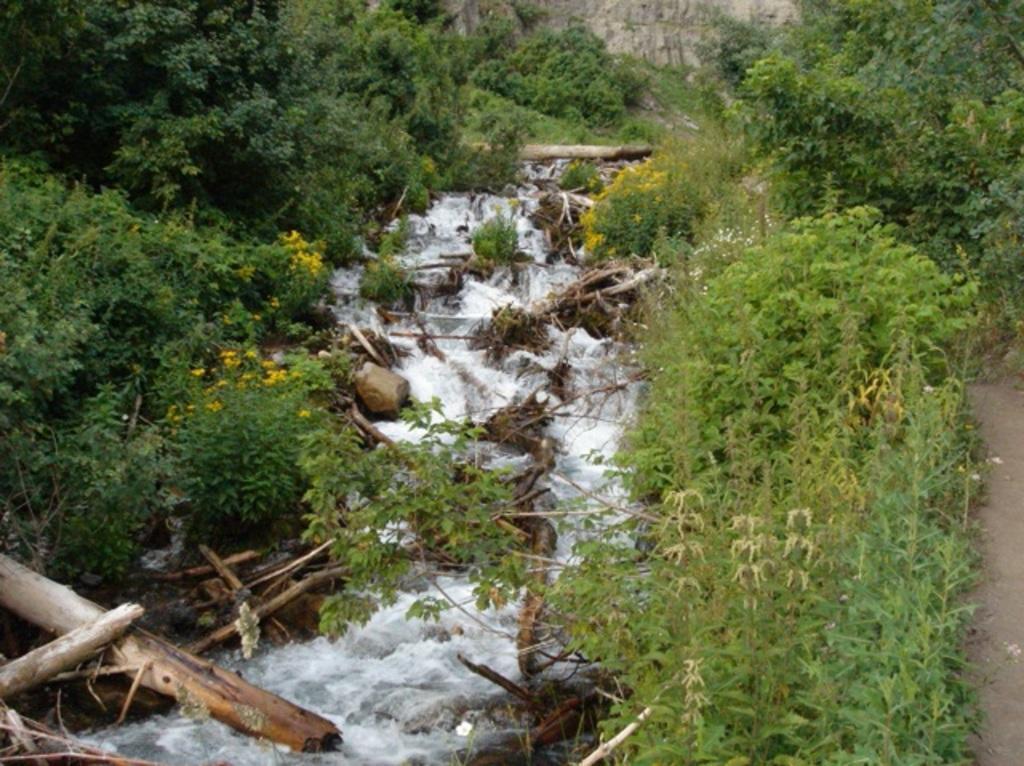How would you summarize this image in a sentence or two? On the left side, there are sticks and rocks in the water and there are trees. On the right side, there are plants and a path. In the background, there are trees, plants, grass and a hill. 